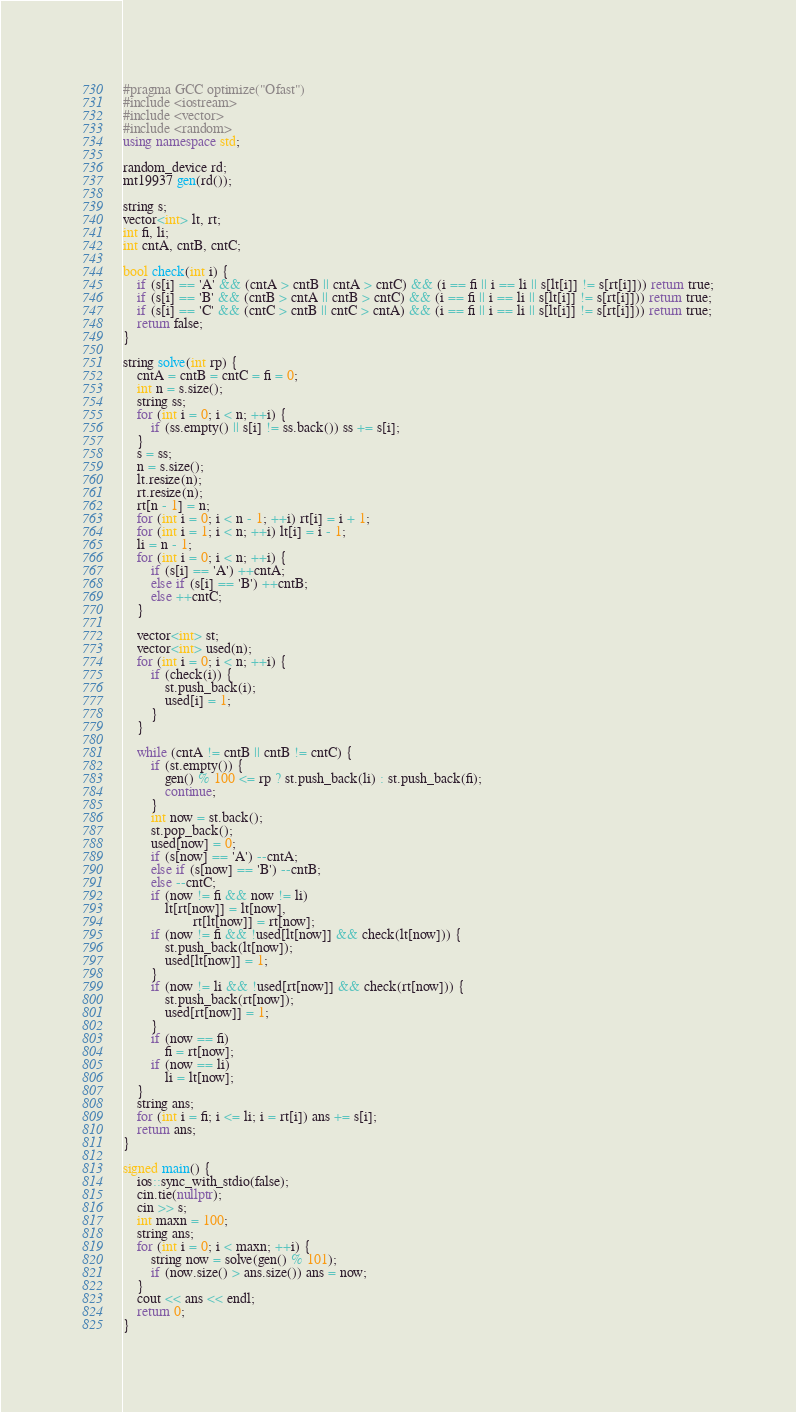<code> <loc_0><loc_0><loc_500><loc_500><_C++_>#pragma GCC optimize("Ofast")
#include <iostream>
#include <vector>
#include <random>
using namespace std;

random_device rd;
mt19937 gen(rd());

string s;
vector<int> lt, rt;
int fi, li;
int cntA, cntB, cntC;

bool check(int i) {
    if (s[i] == 'A' && (cntA > cntB || cntA > cntC) && (i == fi || i == li || s[lt[i]] != s[rt[i]])) return true;
    if (s[i] == 'B' && (cntB > cntA || cntB > cntC) && (i == fi || i == li || s[lt[i]] != s[rt[i]])) return true;
    if (s[i] == 'C' && (cntC > cntB || cntC > cntA) && (i == fi || i == li || s[lt[i]] != s[rt[i]])) return true;
    return false;
}

string solve(int rp) {
    cntA = cntB = cntC = fi = 0;
    int n = s.size();
    string ss;
    for (int i = 0; i < n; ++i) {
        if (ss.empty() || s[i] != ss.back()) ss += s[i];
    }
    s = ss;
    n = s.size();
    lt.resize(n);
    rt.resize(n);
    rt[n - 1] = n;
    for (int i = 0; i < n - 1; ++i) rt[i] = i + 1;
    for (int i = 1; i < n; ++i) lt[i] = i - 1;
    li = n - 1;
    for (int i = 0; i < n; ++i) {
        if (s[i] == 'A') ++cntA;
        else if (s[i] == 'B') ++cntB;
        else ++cntC;
    }

    vector<int> st;
    vector<int> used(n);
    for (int i = 0; i < n; ++i) {
        if (check(i)) {
            st.push_back(i);
            used[i] = 1;
        }
    }

    while (cntA != cntB || cntB != cntC) {
        if (st.empty()) {
            gen() % 100 <= rp ? st.push_back(li) : st.push_back(fi);
            continue;
        }
        int now = st.back();
        st.pop_back();
        used[now] = 0;
        if (s[now] == 'A') --cntA;
        else if (s[now] == 'B') --cntB;
        else --cntC;
        if (now != fi && now != li)
            lt[rt[now]] = lt[now],
                    rt[lt[now]] = rt[now];
        if (now != fi && !used[lt[now]] && check(lt[now])) {
            st.push_back(lt[now]);
            used[lt[now]] = 1;
        }
        if (now != li && !used[rt[now]] && check(rt[now])) {
            st.push_back(rt[now]);
            used[rt[now]] = 1;
        }
        if (now == fi)
            fi = rt[now];
        if (now == li)
            li = lt[now];
    }
    string ans;
    for (int i = fi; i <= li; i = rt[i]) ans += s[i];
    return ans;
}

signed main() {
    ios::sync_with_stdio(false);
    cin.tie(nullptr);
    cin >> s;
    int maxn = 100;
    string ans;
    for (int i = 0; i < maxn; ++i) {
        string now = solve(gen() % 101);
        if (now.size() > ans.size()) ans = now;
    }
    cout << ans << endl;
    return 0;
}
</code> 